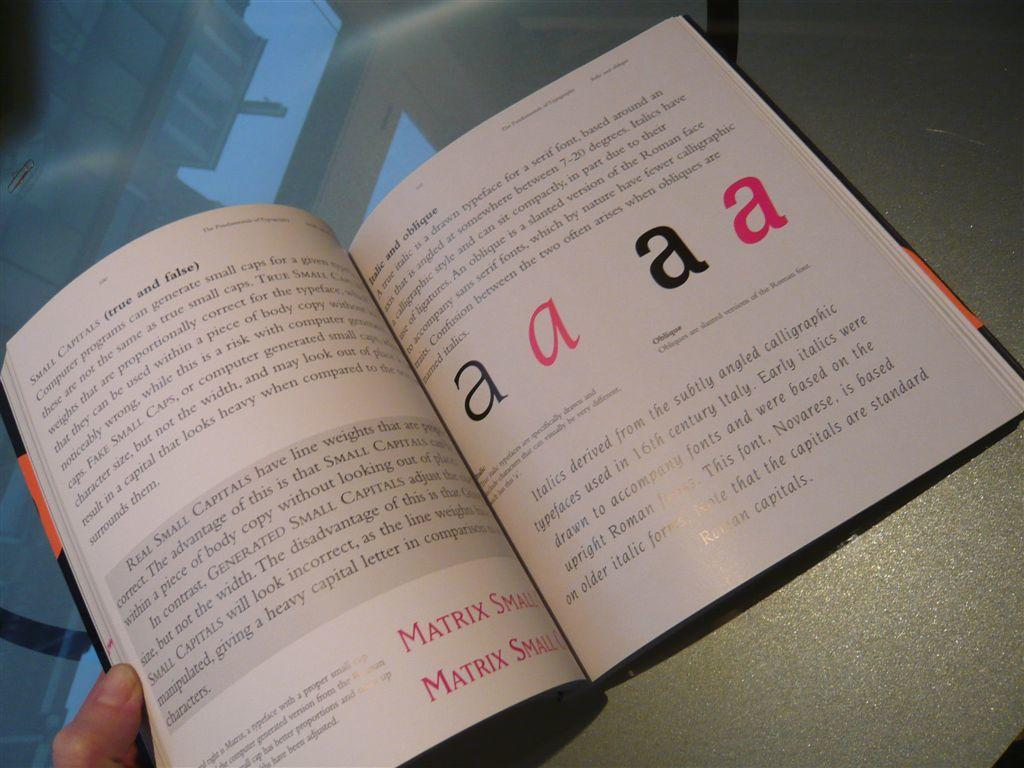<image>
Create a compact narrative representing the image presented. Text in a open book with understanding of Matrix Small a's fonts. 